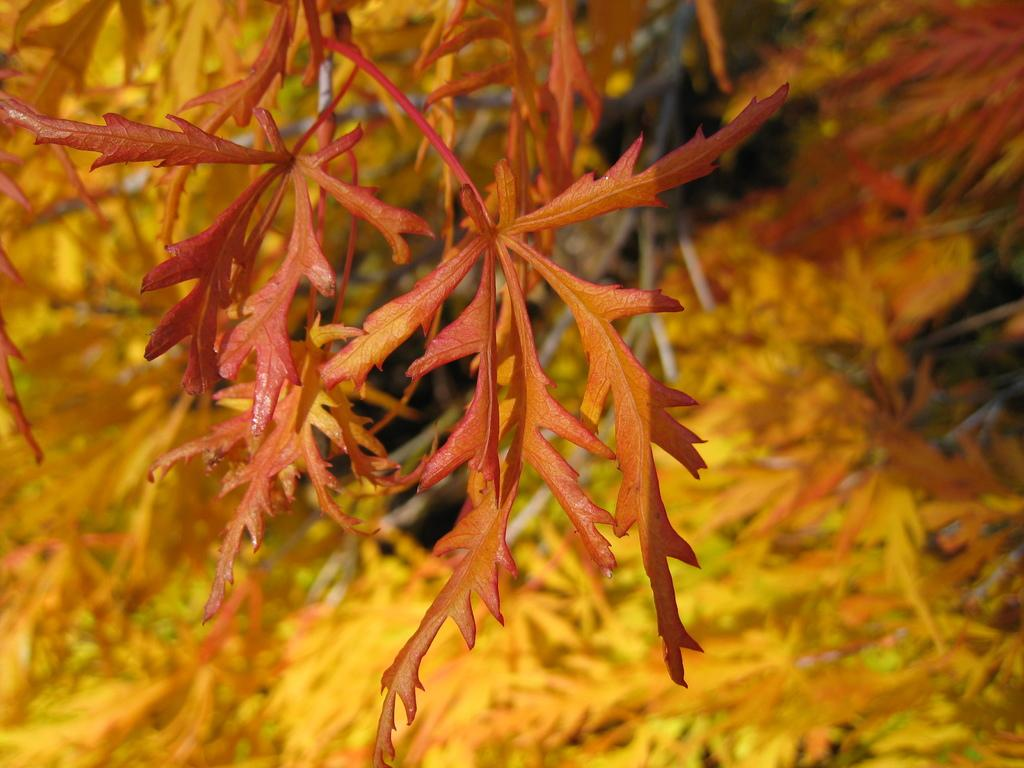What type of vegetation is present in the image? There are leaves in the image. What colors are the leaves? The leaves are of yellow and orange color. Can you describe the background of the image? The background of the image is blurred. What type of soup is being served in the image? There is no soup present in the image; it features leaves of yellow and orange color with a blurred background. 